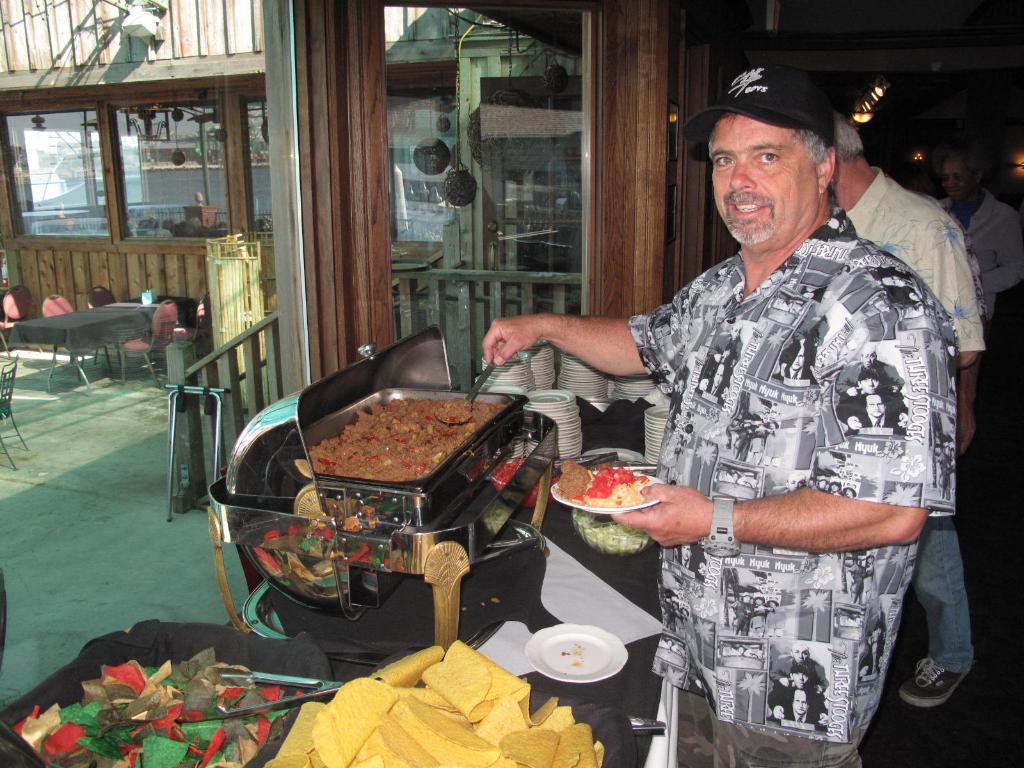How would you summarize this image in a sentence or two? In the picture we can see a man near the table and serving the food on his plate which is on the table and he is black with cap and shirt and beside him we can see few men are standing, and behind the table outside, we can see a wooden house with glasses in it and near it we can see a table and chairs on the path. 